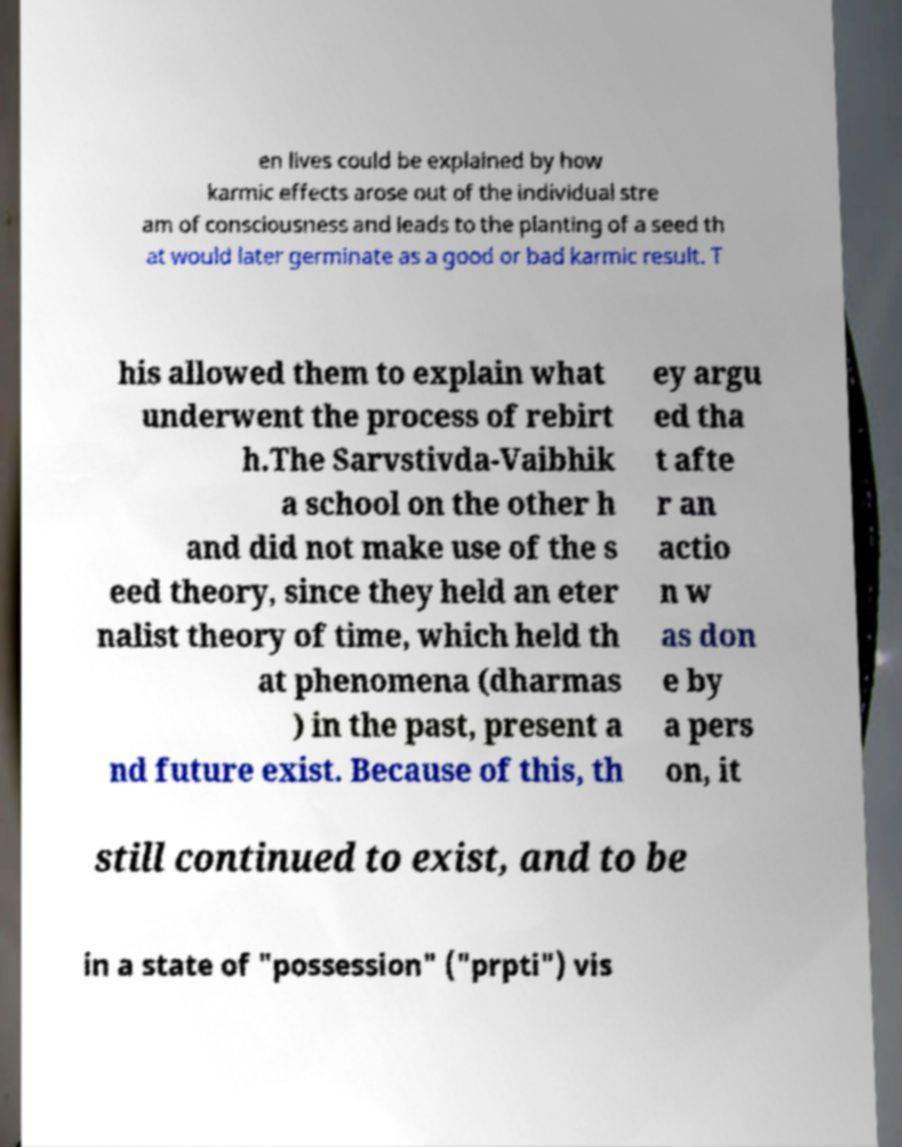Could you extract and type out the text from this image? en lives could be explained by how karmic effects arose out of the individual stre am of consciousness and leads to the planting of a seed th at would later germinate as a good or bad karmic result. T his allowed them to explain what underwent the process of rebirt h.The Sarvstivda-Vaibhik a school on the other h and did not make use of the s eed theory, since they held an eter nalist theory of time, which held th at phenomena (dharmas ) in the past, present a nd future exist. Because of this, th ey argu ed tha t afte r an actio n w as don e by a pers on, it still continued to exist, and to be in a state of "possession" ("prpti") vis 